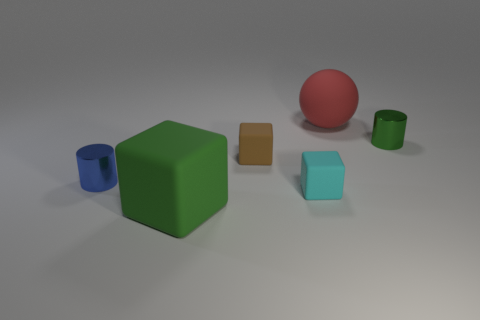Could you describe the lighting in this scene and how it affects the appearance of the objects? Certainly, the lighting in this scene appears soft and diffused, with no harsh shadows, suggesting an overcast sky or a single light source diffused through a filter. This type of lighting minimizes shadows and helps in evenly illuminating all objects, giving a clear view of their colors and shapes without strong light contrasts or deep shadows. 